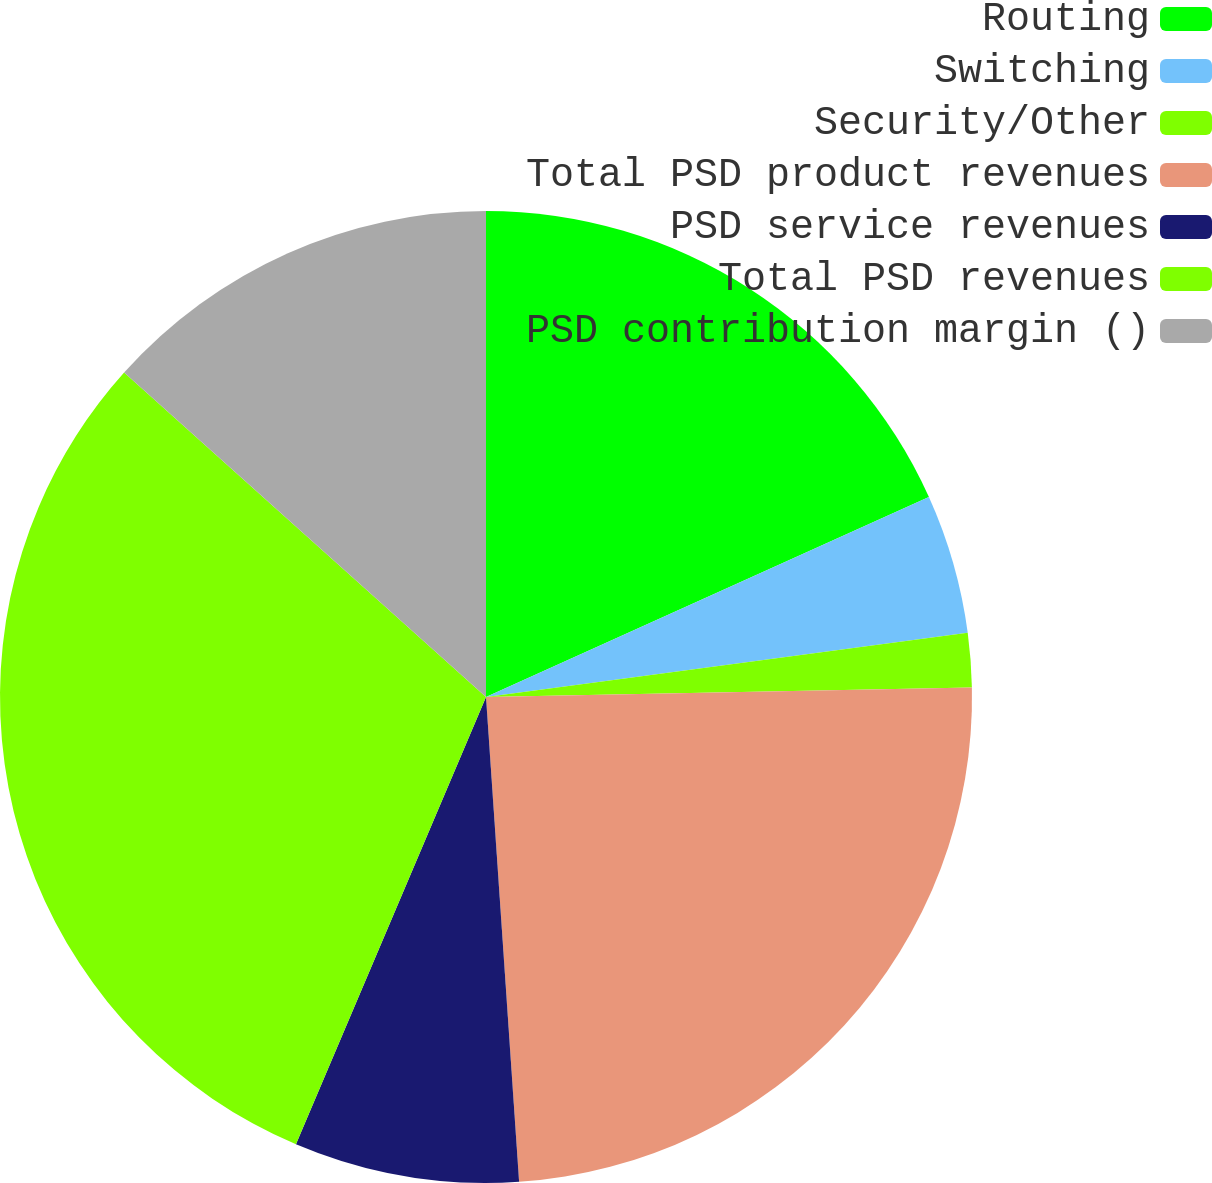Convert chart to OTSL. <chart><loc_0><loc_0><loc_500><loc_500><pie_chart><fcel>Routing<fcel>Switching<fcel>Security/Other<fcel>Total PSD product revenues<fcel>PSD service revenues<fcel>Total PSD revenues<fcel>PSD contribution margin ()<nl><fcel>18.25%<fcel>4.64%<fcel>1.8%<fcel>24.23%<fcel>7.48%<fcel>30.24%<fcel>13.37%<nl></chart> 